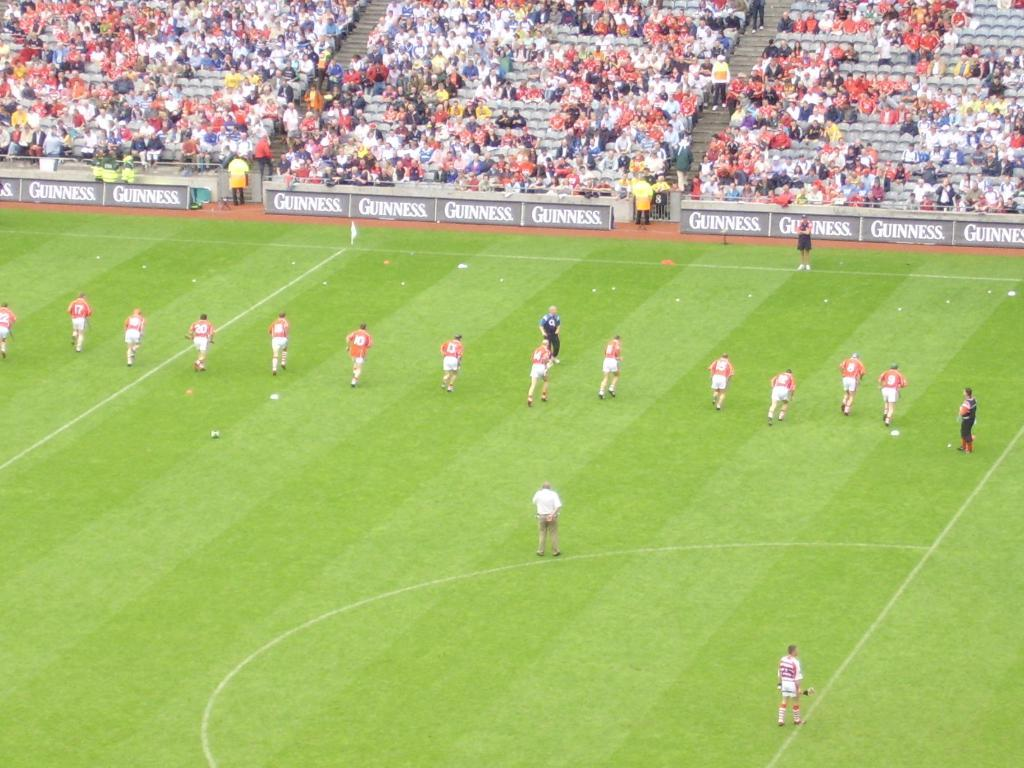<image>
Give a short and clear explanation of the subsequent image. A group of soccer player running towards the Guinness advertising. 